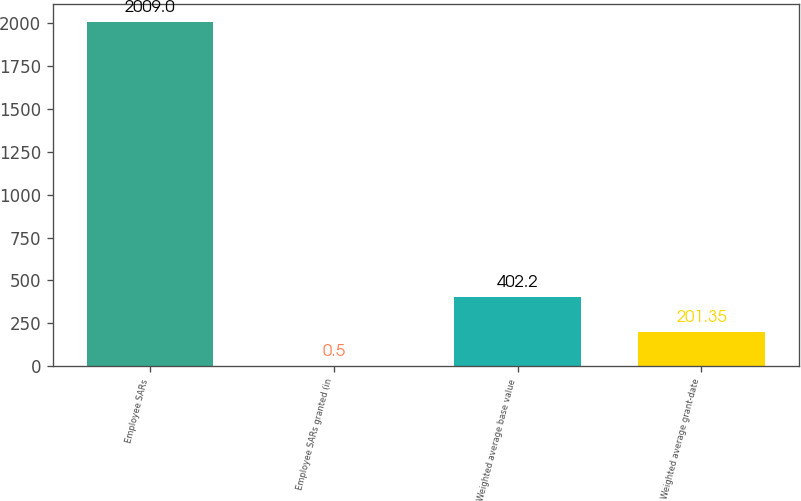Convert chart to OTSL. <chart><loc_0><loc_0><loc_500><loc_500><bar_chart><fcel>Employee SARs<fcel>Employee SARs granted (in<fcel>Weighted average base value<fcel>Weighted average grant-date<nl><fcel>2009<fcel>0.5<fcel>402.2<fcel>201.35<nl></chart> 